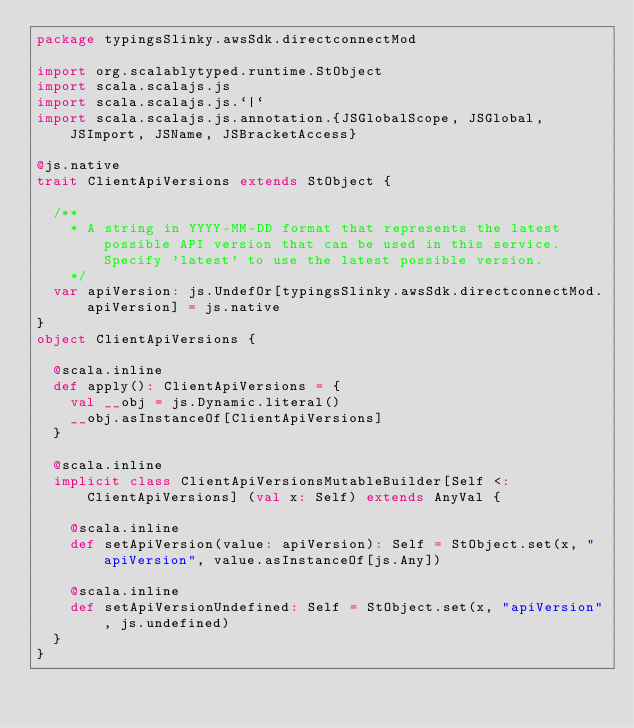<code> <loc_0><loc_0><loc_500><loc_500><_Scala_>package typingsSlinky.awsSdk.directconnectMod

import org.scalablytyped.runtime.StObject
import scala.scalajs.js
import scala.scalajs.js.`|`
import scala.scalajs.js.annotation.{JSGlobalScope, JSGlobal, JSImport, JSName, JSBracketAccess}

@js.native
trait ClientApiVersions extends StObject {
  
  /**
    * A string in YYYY-MM-DD format that represents the latest possible API version that can be used in this service. Specify 'latest' to use the latest possible version.
    */
  var apiVersion: js.UndefOr[typingsSlinky.awsSdk.directconnectMod.apiVersion] = js.native
}
object ClientApiVersions {
  
  @scala.inline
  def apply(): ClientApiVersions = {
    val __obj = js.Dynamic.literal()
    __obj.asInstanceOf[ClientApiVersions]
  }
  
  @scala.inline
  implicit class ClientApiVersionsMutableBuilder[Self <: ClientApiVersions] (val x: Self) extends AnyVal {
    
    @scala.inline
    def setApiVersion(value: apiVersion): Self = StObject.set(x, "apiVersion", value.asInstanceOf[js.Any])
    
    @scala.inline
    def setApiVersionUndefined: Self = StObject.set(x, "apiVersion", js.undefined)
  }
}
</code> 